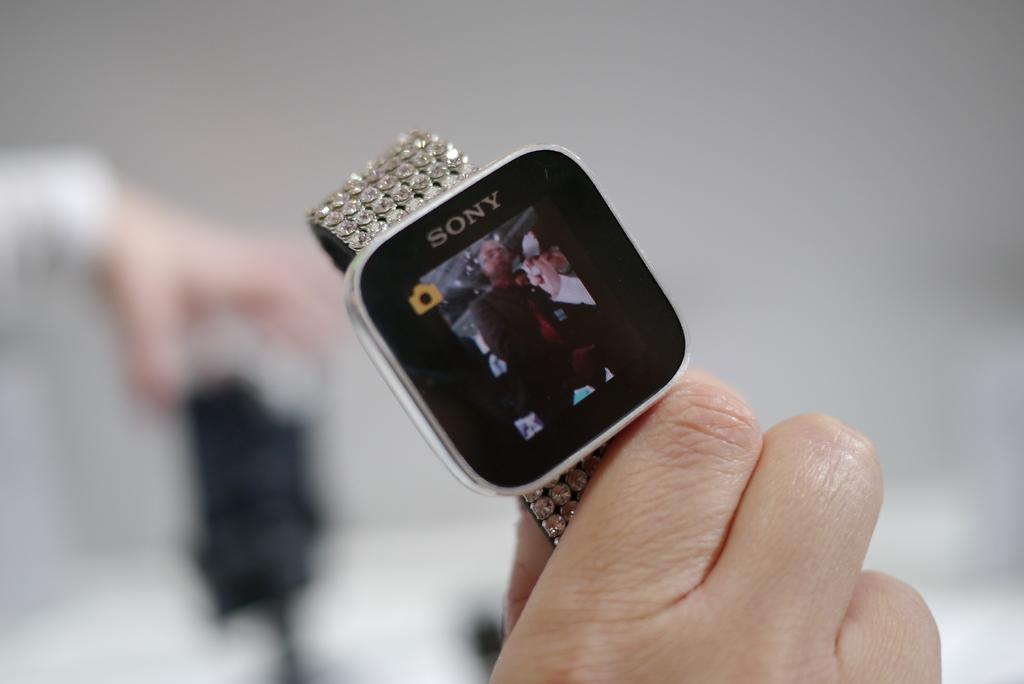<image>
Offer a succinct explanation of the picture presented. A Sony smart watch has a little yellow camera icon in the corner. 